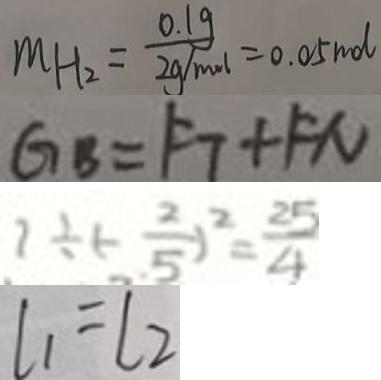Convert formula to latex. <formula><loc_0><loc_0><loc_500><loc_500>M H _ { 2 } = \frac { 0 . 1 g } { 2 g / m o l } = 0 . 0 5 m d 
 G _ { B } = F _ { 7 } + F N 
 1 \div ( - \frac { 2 } { 5 } ) ^ { 2 } = \frac { 2 5 } { 4 } 
 l _ { 1 } = l _ { 2 }</formula> 